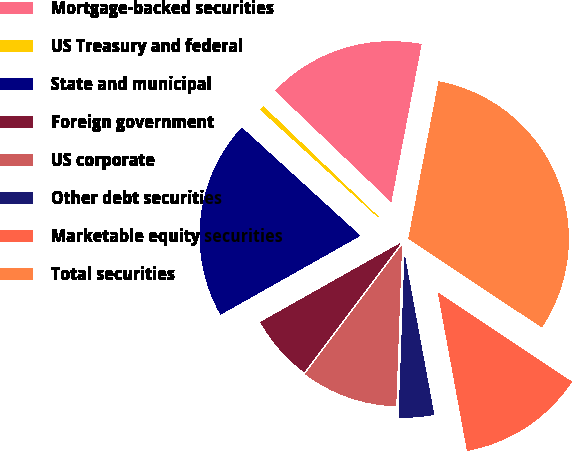Convert chart. <chart><loc_0><loc_0><loc_500><loc_500><pie_chart><fcel>Mortgage-backed securities<fcel>US Treasury and federal<fcel>State and municipal<fcel>Foreign government<fcel>US corporate<fcel>Other debt securities<fcel>Marketable equity securities<fcel>Total securities<nl><fcel>15.85%<fcel>0.39%<fcel>19.95%<fcel>6.58%<fcel>9.67%<fcel>3.48%<fcel>12.76%<fcel>31.32%<nl></chart> 